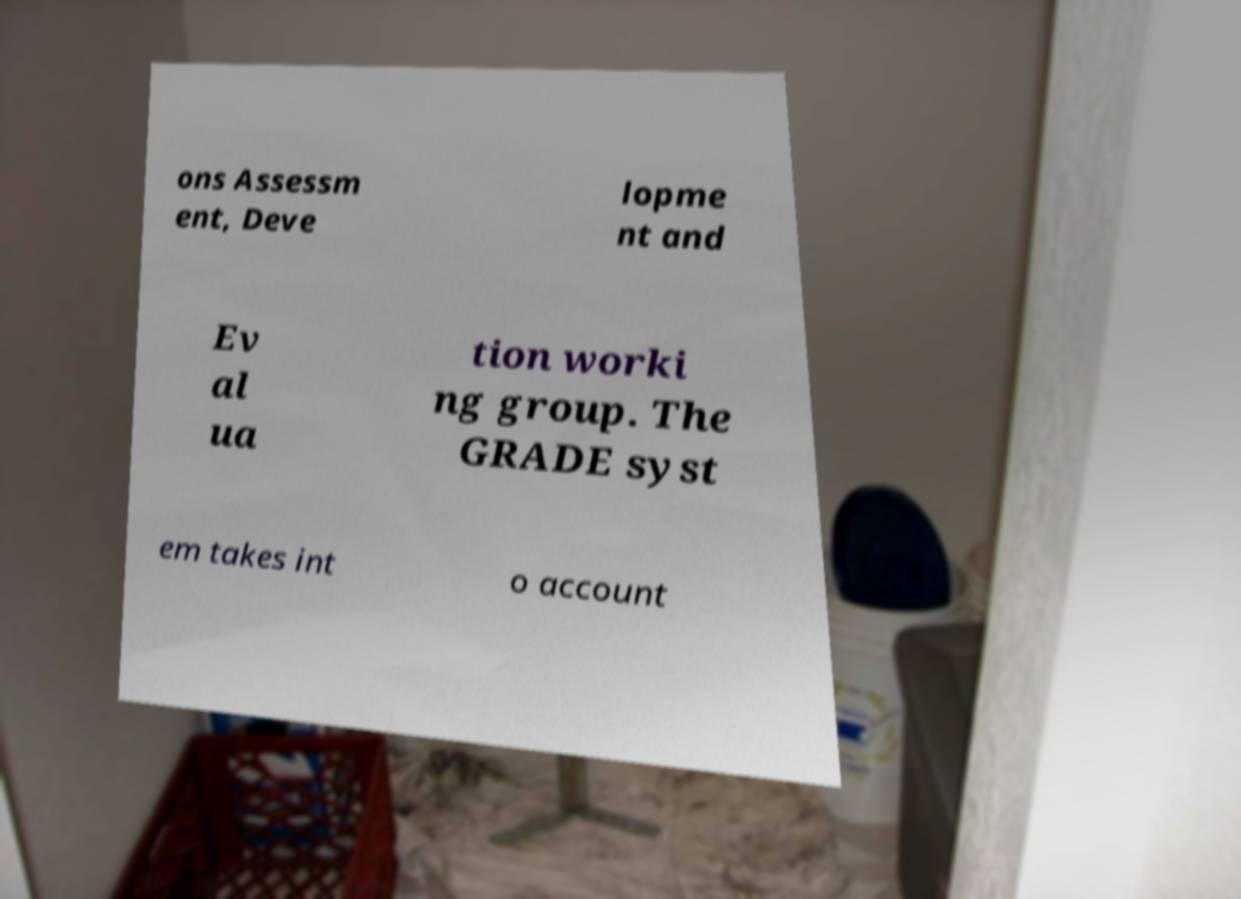Can you accurately transcribe the text from the provided image for me? ons Assessm ent, Deve lopme nt and Ev al ua tion worki ng group. The GRADE syst em takes int o account 